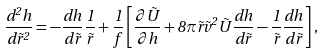Convert formula to latex. <formula><loc_0><loc_0><loc_500><loc_500>\frac { d ^ { 2 } h } { d \tilde { r } ^ { 2 } } = - \frac { d h } { d \tilde { r } } \frac { 1 } { \tilde { r } } + \frac { 1 } { f } \left [ \frac { \partial \tilde { U } } { \partial h } + 8 \pi \tilde { r } \tilde { v } ^ { 2 } \tilde { U } \frac { d h } { d \tilde { r } } - \frac { 1 } { \tilde { r } } \frac { d h } { d \tilde { r } } \right ] ,</formula> 